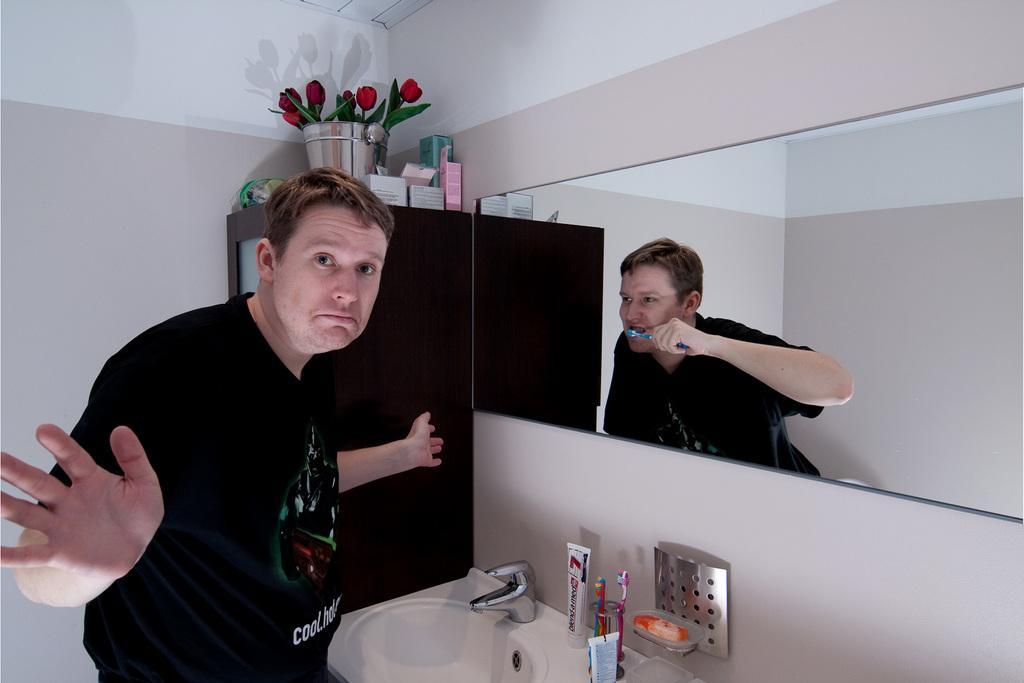Can you describe this image briefly? In this picture I can observe two members. Both are looking similar. On the bottom of the picture I can observe sink and a tap. In the background there is a wall. 